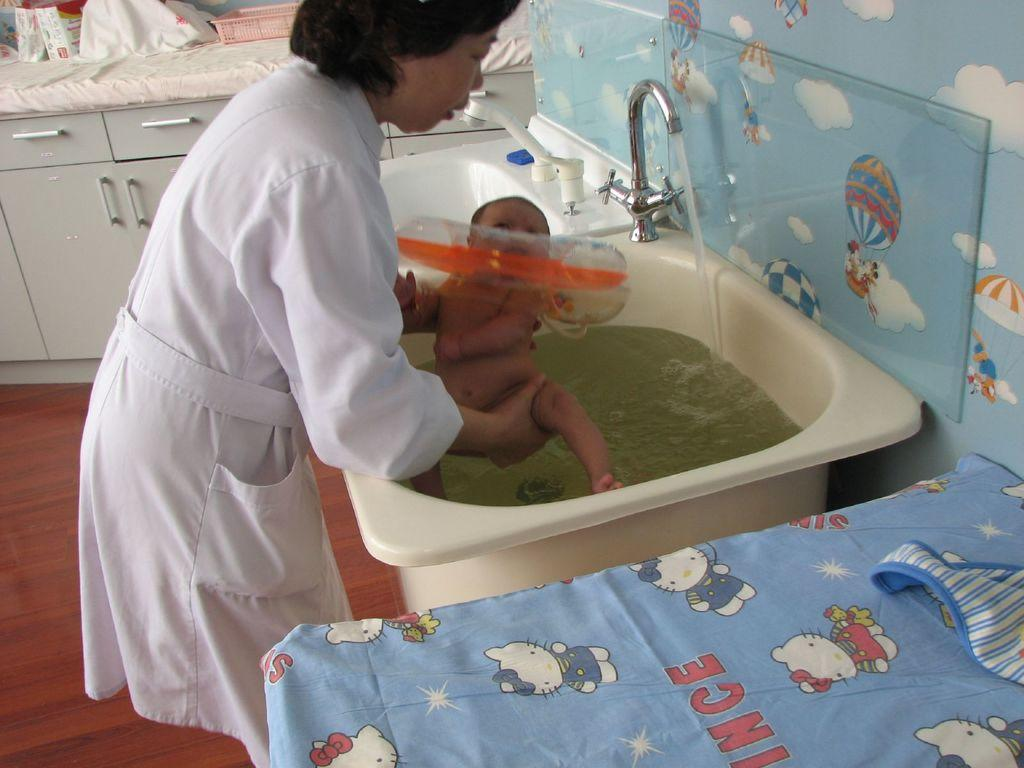Who is the main subject in the image? There is a woman in the image. What is the woman doing in the image? The woman is holding a baby. Where is the woman and baby located in the image? They are in front of a sink. What can be seen on the sink in the image? There is a tap on the sink and water in the sink. What is visible in the background of the image? There are cupboards in the background of the image. What type of journey is the woman and baby embarking on in the image? There is no indication of a journey in the image; it simply shows a woman holding a baby in front of a sink. What type of cannon is present in the image? There is no cannon present in the image. 